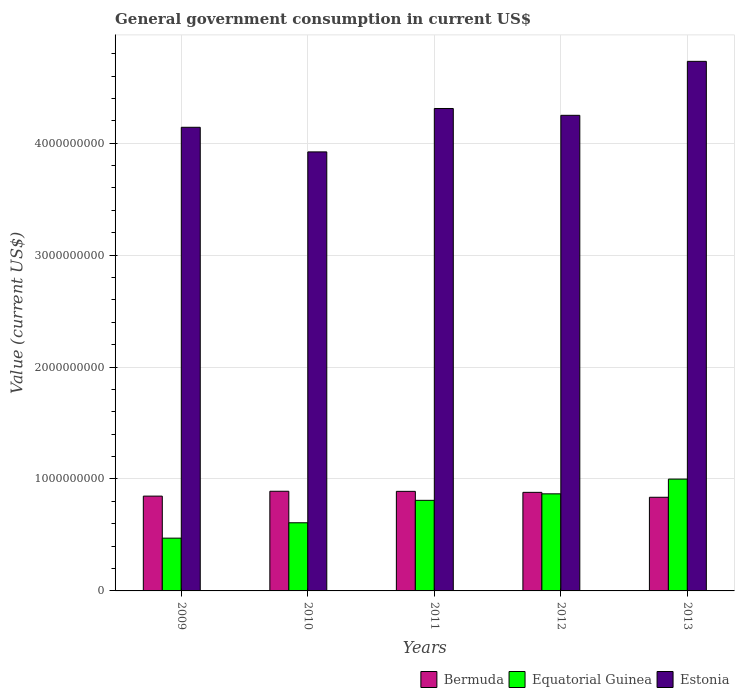How many different coloured bars are there?
Keep it short and to the point. 3. What is the label of the 5th group of bars from the left?
Offer a very short reply. 2013. What is the government conusmption in Estonia in 2012?
Make the answer very short. 4.25e+09. Across all years, what is the maximum government conusmption in Equatorial Guinea?
Your answer should be compact. 9.99e+08. Across all years, what is the minimum government conusmption in Estonia?
Your answer should be compact. 3.92e+09. In which year was the government conusmption in Equatorial Guinea maximum?
Give a very brief answer. 2013. In which year was the government conusmption in Bermuda minimum?
Keep it short and to the point. 2013. What is the total government conusmption in Equatorial Guinea in the graph?
Keep it short and to the point. 3.76e+09. What is the difference between the government conusmption in Bermuda in 2010 and that in 2013?
Ensure brevity in your answer.  5.36e+07. What is the difference between the government conusmption in Equatorial Guinea in 2010 and the government conusmption in Bermuda in 2009?
Your answer should be very brief. -2.38e+08. What is the average government conusmption in Estonia per year?
Keep it short and to the point. 4.27e+09. In the year 2009, what is the difference between the government conusmption in Estonia and government conusmption in Equatorial Guinea?
Your answer should be compact. 3.67e+09. In how many years, is the government conusmption in Equatorial Guinea greater than 3800000000 US$?
Keep it short and to the point. 0. What is the ratio of the government conusmption in Estonia in 2009 to that in 2012?
Your response must be concise. 0.97. Is the difference between the government conusmption in Estonia in 2009 and 2011 greater than the difference between the government conusmption in Equatorial Guinea in 2009 and 2011?
Offer a terse response. Yes. What is the difference between the highest and the second highest government conusmption in Equatorial Guinea?
Your answer should be compact. 1.32e+08. What is the difference between the highest and the lowest government conusmption in Equatorial Guinea?
Your answer should be compact. 5.27e+08. What does the 3rd bar from the left in 2010 represents?
Keep it short and to the point. Estonia. What does the 3rd bar from the right in 2013 represents?
Your answer should be compact. Bermuda. How many bars are there?
Offer a very short reply. 15. Are all the bars in the graph horizontal?
Offer a terse response. No. How many years are there in the graph?
Provide a short and direct response. 5. Are the values on the major ticks of Y-axis written in scientific E-notation?
Give a very brief answer. No. How are the legend labels stacked?
Make the answer very short. Horizontal. What is the title of the graph?
Offer a terse response. General government consumption in current US$. Does "East Asia (developing only)" appear as one of the legend labels in the graph?
Offer a very short reply. No. What is the label or title of the X-axis?
Provide a succinct answer. Years. What is the label or title of the Y-axis?
Your answer should be very brief. Value (current US$). What is the Value (current US$) in Bermuda in 2009?
Offer a very short reply. 8.47e+08. What is the Value (current US$) in Equatorial Guinea in 2009?
Offer a very short reply. 4.71e+08. What is the Value (current US$) of Estonia in 2009?
Ensure brevity in your answer.  4.14e+09. What is the Value (current US$) in Bermuda in 2010?
Provide a short and direct response. 8.90e+08. What is the Value (current US$) of Equatorial Guinea in 2010?
Offer a terse response. 6.09e+08. What is the Value (current US$) of Estonia in 2010?
Your answer should be compact. 3.92e+09. What is the Value (current US$) in Bermuda in 2011?
Your answer should be very brief. 8.90e+08. What is the Value (current US$) of Equatorial Guinea in 2011?
Provide a short and direct response. 8.09e+08. What is the Value (current US$) of Estonia in 2011?
Your response must be concise. 4.31e+09. What is the Value (current US$) of Bermuda in 2012?
Make the answer very short. 8.81e+08. What is the Value (current US$) in Equatorial Guinea in 2012?
Your response must be concise. 8.67e+08. What is the Value (current US$) in Estonia in 2012?
Your answer should be compact. 4.25e+09. What is the Value (current US$) of Bermuda in 2013?
Make the answer very short. 8.37e+08. What is the Value (current US$) of Equatorial Guinea in 2013?
Provide a succinct answer. 9.99e+08. What is the Value (current US$) in Estonia in 2013?
Offer a terse response. 4.73e+09. Across all years, what is the maximum Value (current US$) in Bermuda?
Offer a very short reply. 8.90e+08. Across all years, what is the maximum Value (current US$) of Equatorial Guinea?
Offer a terse response. 9.99e+08. Across all years, what is the maximum Value (current US$) of Estonia?
Make the answer very short. 4.73e+09. Across all years, what is the minimum Value (current US$) of Bermuda?
Offer a very short reply. 8.37e+08. Across all years, what is the minimum Value (current US$) in Equatorial Guinea?
Make the answer very short. 4.71e+08. Across all years, what is the minimum Value (current US$) in Estonia?
Make the answer very short. 3.92e+09. What is the total Value (current US$) in Bermuda in the graph?
Give a very brief answer. 4.34e+09. What is the total Value (current US$) of Equatorial Guinea in the graph?
Your answer should be very brief. 3.76e+09. What is the total Value (current US$) in Estonia in the graph?
Your answer should be very brief. 2.14e+1. What is the difference between the Value (current US$) in Bermuda in 2009 and that in 2010?
Your response must be concise. -4.34e+07. What is the difference between the Value (current US$) in Equatorial Guinea in 2009 and that in 2010?
Your answer should be compact. -1.37e+08. What is the difference between the Value (current US$) of Estonia in 2009 and that in 2010?
Keep it short and to the point. 2.20e+08. What is the difference between the Value (current US$) in Bermuda in 2009 and that in 2011?
Give a very brief answer. -4.26e+07. What is the difference between the Value (current US$) of Equatorial Guinea in 2009 and that in 2011?
Your answer should be compact. -3.38e+08. What is the difference between the Value (current US$) of Estonia in 2009 and that in 2011?
Your response must be concise. -1.68e+08. What is the difference between the Value (current US$) of Bermuda in 2009 and that in 2012?
Offer a terse response. -3.37e+07. What is the difference between the Value (current US$) in Equatorial Guinea in 2009 and that in 2012?
Provide a succinct answer. -3.96e+08. What is the difference between the Value (current US$) of Estonia in 2009 and that in 2012?
Your answer should be compact. -1.07e+08. What is the difference between the Value (current US$) in Bermuda in 2009 and that in 2013?
Give a very brief answer. 1.03e+07. What is the difference between the Value (current US$) of Equatorial Guinea in 2009 and that in 2013?
Offer a very short reply. -5.27e+08. What is the difference between the Value (current US$) of Estonia in 2009 and that in 2013?
Your answer should be very brief. -5.89e+08. What is the difference between the Value (current US$) of Bermuda in 2010 and that in 2011?
Ensure brevity in your answer.  8.17e+05. What is the difference between the Value (current US$) in Equatorial Guinea in 2010 and that in 2011?
Your answer should be compact. -2.00e+08. What is the difference between the Value (current US$) in Estonia in 2010 and that in 2011?
Make the answer very short. -3.88e+08. What is the difference between the Value (current US$) in Bermuda in 2010 and that in 2012?
Your answer should be very brief. 9.67e+06. What is the difference between the Value (current US$) in Equatorial Guinea in 2010 and that in 2012?
Offer a very short reply. -2.58e+08. What is the difference between the Value (current US$) of Estonia in 2010 and that in 2012?
Your response must be concise. -3.27e+08. What is the difference between the Value (current US$) in Bermuda in 2010 and that in 2013?
Ensure brevity in your answer.  5.36e+07. What is the difference between the Value (current US$) in Equatorial Guinea in 2010 and that in 2013?
Make the answer very short. -3.90e+08. What is the difference between the Value (current US$) in Estonia in 2010 and that in 2013?
Your answer should be very brief. -8.09e+08. What is the difference between the Value (current US$) of Bermuda in 2011 and that in 2012?
Provide a short and direct response. 8.85e+06. What is the difference between the Value (current US$) in Equatorial Guinea in 2011 and that in 2012?
Ensure brevity in your answer.  -5.80e+07. What is the difference between the Value (current US$) in Estonia in 2011 and that in 2012?
Give a very brief answer. 6.11e+07. What is the difference between the Value (current US$) in Bermuda in 2011 and that in 2013?
Make the answer very short. 5.28e+07. What is the difference between the Value (current US$) of Equatorial Guinea in 2011 and that in 2013?
Your response must be concise. -1.90e+08. What is the difference between the Value (current US$) of Estonia in 2011 and that in 2013?
Your response must be concise. -4.21e+08. What is the difference between the Value (current US$) in Bermuda in 2012 and that in 2013?
Your answer should be compact. 4.40e+07. What is the difference between the Value (current US$) in Equatorial Guinea in 2012 and that in 2013?
Your answer should be very brief. -1.32e+08. What is the difference between the Value (current US$) in Estonia in 2012 and that in 2013?
Keep it short and to the point. -4.82e+08. What is the difference between the Value (current US$) of Bermuda in 2009 and the Value (current US$) of Equatorial Guinea in 2010?
Give a very brief answer. 2.38e+08. What is the difference between the Value (current US$) in Bermuda in 2009 and the Value (current US$) in Estonia in 2010?
Provide a succinct answer. -3.08e+09. What is the difference between the Value (current US$) of Equatorial Guinea in 2009 and the Value (current US$) of Estonia in 2010?
Keep it short and to the point. -3.45e+09. What is the difference between the Value (current US$) in Bermuda in 2009 and the Value (current US$) in Equatorial Guinea in 2011?
Provide a short and direct response. 3.76e+07. What is the difference between the Value (current US$) in Bermuda in 2009 and the Value (current US$) in Estonia in 2011?
Offer a terse response. -3.46e+09. What is the difference between the Value (current US$) in Equatorial Guinea in 2009 and the Value (current US$) in Estonia in 2011?
Ensure brevity in your answer.  -3.84e+09. What is the difference between the Value (current US$) in Bermuda in 2009 and the Value (current US$) in Equatorial Guinea in 2012?
Ensure brevity in your answer.  -2.04e+07. What is the difference between the Value (current US$) in Bermuda in 2009 and the Value (current US$) in Estonia in 2012?
Your answer should be very brief. -3.40e+09. What is the difference between the Value (current US$) of Equatorial Guinea in 2009 and the Value (current US$) of Estonia in 2012?
Offer a terse response. -3.78e+09. What is the difference between the Value (current US$) in Bermuda in 2009 and the Value (current US$) in Equatorial Guinea in 2013?
Ensure brevity in your answer.  -1.52e+08. What is the difference between the Value (current US$) of Bermuda in 2009 and the Value (current US$) of Estonia in 2013?
Your response must be concise. -3.88e+09. What is the difference between the Value (current US$) of Equatorial Guinea in 2009 and the Value (current US$) of Estonia in 2013?
Your answer should be compact. -4.26e+09. What is the difference between the Value (current US$) in Bermuda in 2010 and the Value (current US$) in Equatorial Guinea in 2011?
Give a very brief answer. 8.10e+07. What is the difference between the Value (current US$) in Bermuda in 2010 and the Value (current US$) in Estonia in 2011?
Your answer should be very brief. -3.42e+09. What is the difference between the Value (current US$) of Equatorial Guinea in 2010 and the Value (current US$) of Estonia in 2011?
Offer a very short reply. -3.70e+09. What is the difference between the Value (current US$) of Bermuda in 2010 and the Value (current US$) of Equatorial Guinea in 2012?
Offer a terse response. 2.30e+07. What is the difference between the Value (current US$) in Bermuda in 2010 and the Value (current US$) in Estonia in 2012?
Give a very brief answer. -3.36e+09. What is the difference between the Value (current US$) in Equatorial Guinea in 2010 and the Value (current US$) in Estonia in 2012?
Provide a succinct answer. -3.64e+09. What is the difference between the Value (current US$) of Bermuda in 2010 and the Value (current US$) of Equatorial Guinea in 2013?
Offer a terse response. -1.09e+08. What is the difference between the Value (current US$) of Bermuda in 2010 and the Value (current US$) of Estonia in 2013?
Offer a terse response. -3.84e+09. What is the difference between the Value (current US$) of Equatorial Guinea in 2010 and the Value (current US$) of Estonia in 2013?
Your answer should be compact. -4.12e+09. What is the difference between the Value (current US$) of Bermuda in 2011 and the Value (current US$) of Equatorial Guinea in 2012?
Your response must be concise. 2.22e+07. What is the difference between the Value (current US$) of Bermuda in 2011 and the Value (current US$) of Estonia in 2012?
Your answer should be compact. -3.36e+09. What is the difference between the Value (current US$) in Equatorial Guinea in 2011 and the Value (current US$) in Estonia in 2012?
Offer a terse response. -3.44e+09. What is the difference between the Value (current US$) of Bermuda in 2011 and the Value (current US$) of Equatorial Guinea in 2013?
Offer a very short reply. -1.09e+08. What is the difference between the Value (current US$) in Bermuda in 2011 and the Value (current US$) in Estonia in 2013?
Ensure brevity in your answer.  -3.84e+09. What is the difference between the Value (current US$) in Equatorial Guinea in 2011 and the Value (current US$) in Estonia in 2013?
Provide a succinct answer. -3.92e+09. What is the difference between the Value (current US$) of Bermuda in 2012 and the Value (current US$) of Equatorial Guinea in 2013?
Give a very brief answer. -1.18e+08. What is the difference between the Value (current US$) of Bermuda in 2012 and the Value (current US$) of Estonia in 2013?
Provide a succinct answer. -3.85e+09. What is the difference between the Value (current US$) in Equatorial Guinea in 2012 and the Value (current US$) in Estonia in 2013?
Ensure brevity in your answer.  -3.86e+09. What is the average Value (current US$) of Bermuda per year?
Your answer should be very brief. 8.69e+08. What is the average Value (current US$) of Equatorial Guinea per year?
Your answer should be very brief. 7.51e+08. What is the average Value (current US$) in Estonia per year?
Your response must be concise. 4.27e+09. In the year 2009, what is the difference between the Value (current US$) in Bermuda and Value (current US$) in Equatorial Guinea?
Keep it short and to the point. 3.75e+08. In the year 2009, what is the difference between the Value (current US$) in Bermuda and Value (current US$) in Estonia?
Your answer should be compact. -3.30e+09. In the year 2009, what is the difference between the Value (current US$) in Equatorial Guinea and Value (current US$) in Estonia?
Your response must be concise. -3.67e+09. In the year 2010, what is the difference between the Value (current US$) of Bermuda and Value (current US$) of Equatorial Guinea?
Provide a succinct answer. 2.81e+08. In the year 2010, what is the difference between the Value (current US$) in Bermuda and Value (current US$) in Estonia?
Your response must be concise. -3.03e+09. In the year 2010, what is the difference between the Value (current US$) of Equatorial Guinea and Value (current US$) of Estonia?
Keep it short and to the point. -3.31e+09. In the year 2011, what is the difference between the Value (current US$) of Bermuda and Value (current US$) of Equatorial Guinea?
Provide a succinct answer. 8.02e+07. In the year 2011, what is the difference between the Value (current US$) in Bermuda and Value (current US$) in Estonia?
Give a very brief answer. -3.42e+09. In the year 2011, what is the difference between the Value (current US$) of Equatorial Guinea and Value (current US$) of Estonia?
Your response must be concise. -3.50e+09. In the year 2012, what is the difference between the Value (current US$) in Bermuda and Value (current US$) in Equatorial Guinea?
Your answer should be compact. 1.34e+07. In the year 2012, what is the difference between the Value (current US$) of Bermuda and Value (current US$) of Estonia?
Make the answer very short. -3.37e+09. In the year 2012, what is the difference between the Value (current US$) in Equatorial Guinea and Value (current US$) in Estonia?
Offer a very short reply. -3.38e+09. In the year 2013, what is the difference between the Value (current US$) in Bermuda and Value (current US$) in Equatorial Guinea?
Make the answer very short. -1.62e+08. In the year 2013, what is the difference between the Value (current US$) in Bermuda and Value (current US$) in Estonia?
Give a very brief answer. -3.89e+09. In the year 2013, what is the difference between the Value (current US$) in Equatorial Guinea and Value (current US$) in Estonia?
Offer a terse response. -3.73e+09. What is the ratio of the Value (current US$) of Bermuda in 2009 to that in 2010?
Offer a terse response. 0.95. What is the ratio of the Value (current US$) in Equatorial Guinea in 2009 to that in 2010?
Give a very brief answer. 0.77. What is the ratio of the Value (current US$) of Estonia in 2009 to that in 2010?
Keep it short and to the point. 1.06. What is the ratio of the Value (current US$) in Bermuda in 2009 to that in 2011?
Keep it short and to the point. 0.95. What is the ratio of the Value (current US$) in Equatorial Guinea in 2009 to that in 2011?
Provide a short and direct response. 0.58. What is the ratio of the Value (current US$) of Bermuda in 2009 to that in 2012?
Your answer should be very brief. 0.96. What is the ratio of the Value (current US$) of Equatorial Guinea in 2009 to that in 2012?
Offer a terse response. 0.54. What is the ratio of the Value (current US$) in Estonia in 2009 to that in 2012?
Provide a short and direct response. 0.97. What is the ratio of the Value (current US$) in Bermuda in 2009 to that in 2013?
Your answer should be compact. 1.01. What is the ratio of the Value (current US$) of Equatorial Guinea in 2009 to that in 2013?
Offer a very short reply. 0.47. What is the ratio of the Value (current US$) in Estonia in 2009 to that in 2013?
Your response must be concise. 0.88. What is the ratio of the Value (current US$) in Bermuda in 2010 to that in 2011?
Offer a very short reply. 1. What is the ratio of the Value (current US$) in Equatorial Guinea in 2010 to that in 2011?
Provide a succinct answer. 0.75. What is the ratio of the Value (current US$) in Estonia in 2010 to that in 2011?
Ensure brevity in your answer.  0.91. What is the ratio of the Value (current US$) of Equatorial Guinea in 2010 to that in 2012?
Give a very brief answer. 0.7. What is the ratio of the Value (current US$) in Estonia in 2010 to that in 2012?
Keep it short and to the point. 0.92. What is the ratio of the Value (current US$) in Bermuda in 2010 to that in 2013?
Make the answer very short. 1.06. What is the ratio of the Value (current US$) in Equatorial Guinea in 2010 to that in 2013?
Keep it short and to the point. 0.61. What is the ratio of the Value (current US$) in Estonia in 2010 to that in 2013?
Keep it short and to the point. 0.83. What is the ratio of the Value (current US$) of Equatorial Guinea in 2011 to that in 2012?
Offer a very short reply. 0.93. What is the ratio of the Value (current US$) in Estonia in 2011 to that in 2012?
Make the answer very short. 1.01. What is the ratio of the Value (current US$) in Bermuda in 2011 to that in 2013?
Provide a short and direct response. 1.06. What is the ratio of the Value (current US$) in Equatorial Guinea in 2011 to that in 2013?
Offer a terse response. 0.81. What is the ratio of the Value (current US$) in Estonia in 2011 to that in 2013?
Offer a terse response. 0.91. What is the ratio of the Value (current US$) of Bermuda in 2012 to that in 2013?
Offer a terse response. 1.05. What is the ratio of the Value (current US$) of Equatorial Guinea in 2012 to that in 2013?
Provide a short and direct response. 0.87. What is the ratio of the Value (current US$) of Estonia in 2012 to that in 2013?
Provide a succinct answer. 0.9. What is the difference between the highest and the second highest Value (current US$) in Bermuda?
Offer a terse response. 8.17e+05. What is the difference between the highest and the second highest Value (current US$) in Equatorial Guinea?
Give a very brief answer. 1.32e+08. What is the difference between the highest and the second highest Value (current US$) in Estonia?
Your response must be concise. 4.21e+08. What is the difference between the highest and the lowest Value (current US$) in Bermuda?
Ensure brevity in your answer.  5.36e+07. What is the difference between the highest and the lowest Value (current US$) of Equatorial Guinea?
Your answer should be very brief. 5.27e+08. What is the difference between the highest and the lowest Value (current US$) in Estonia?
Provide a short and direct response. 8.09e+08. 